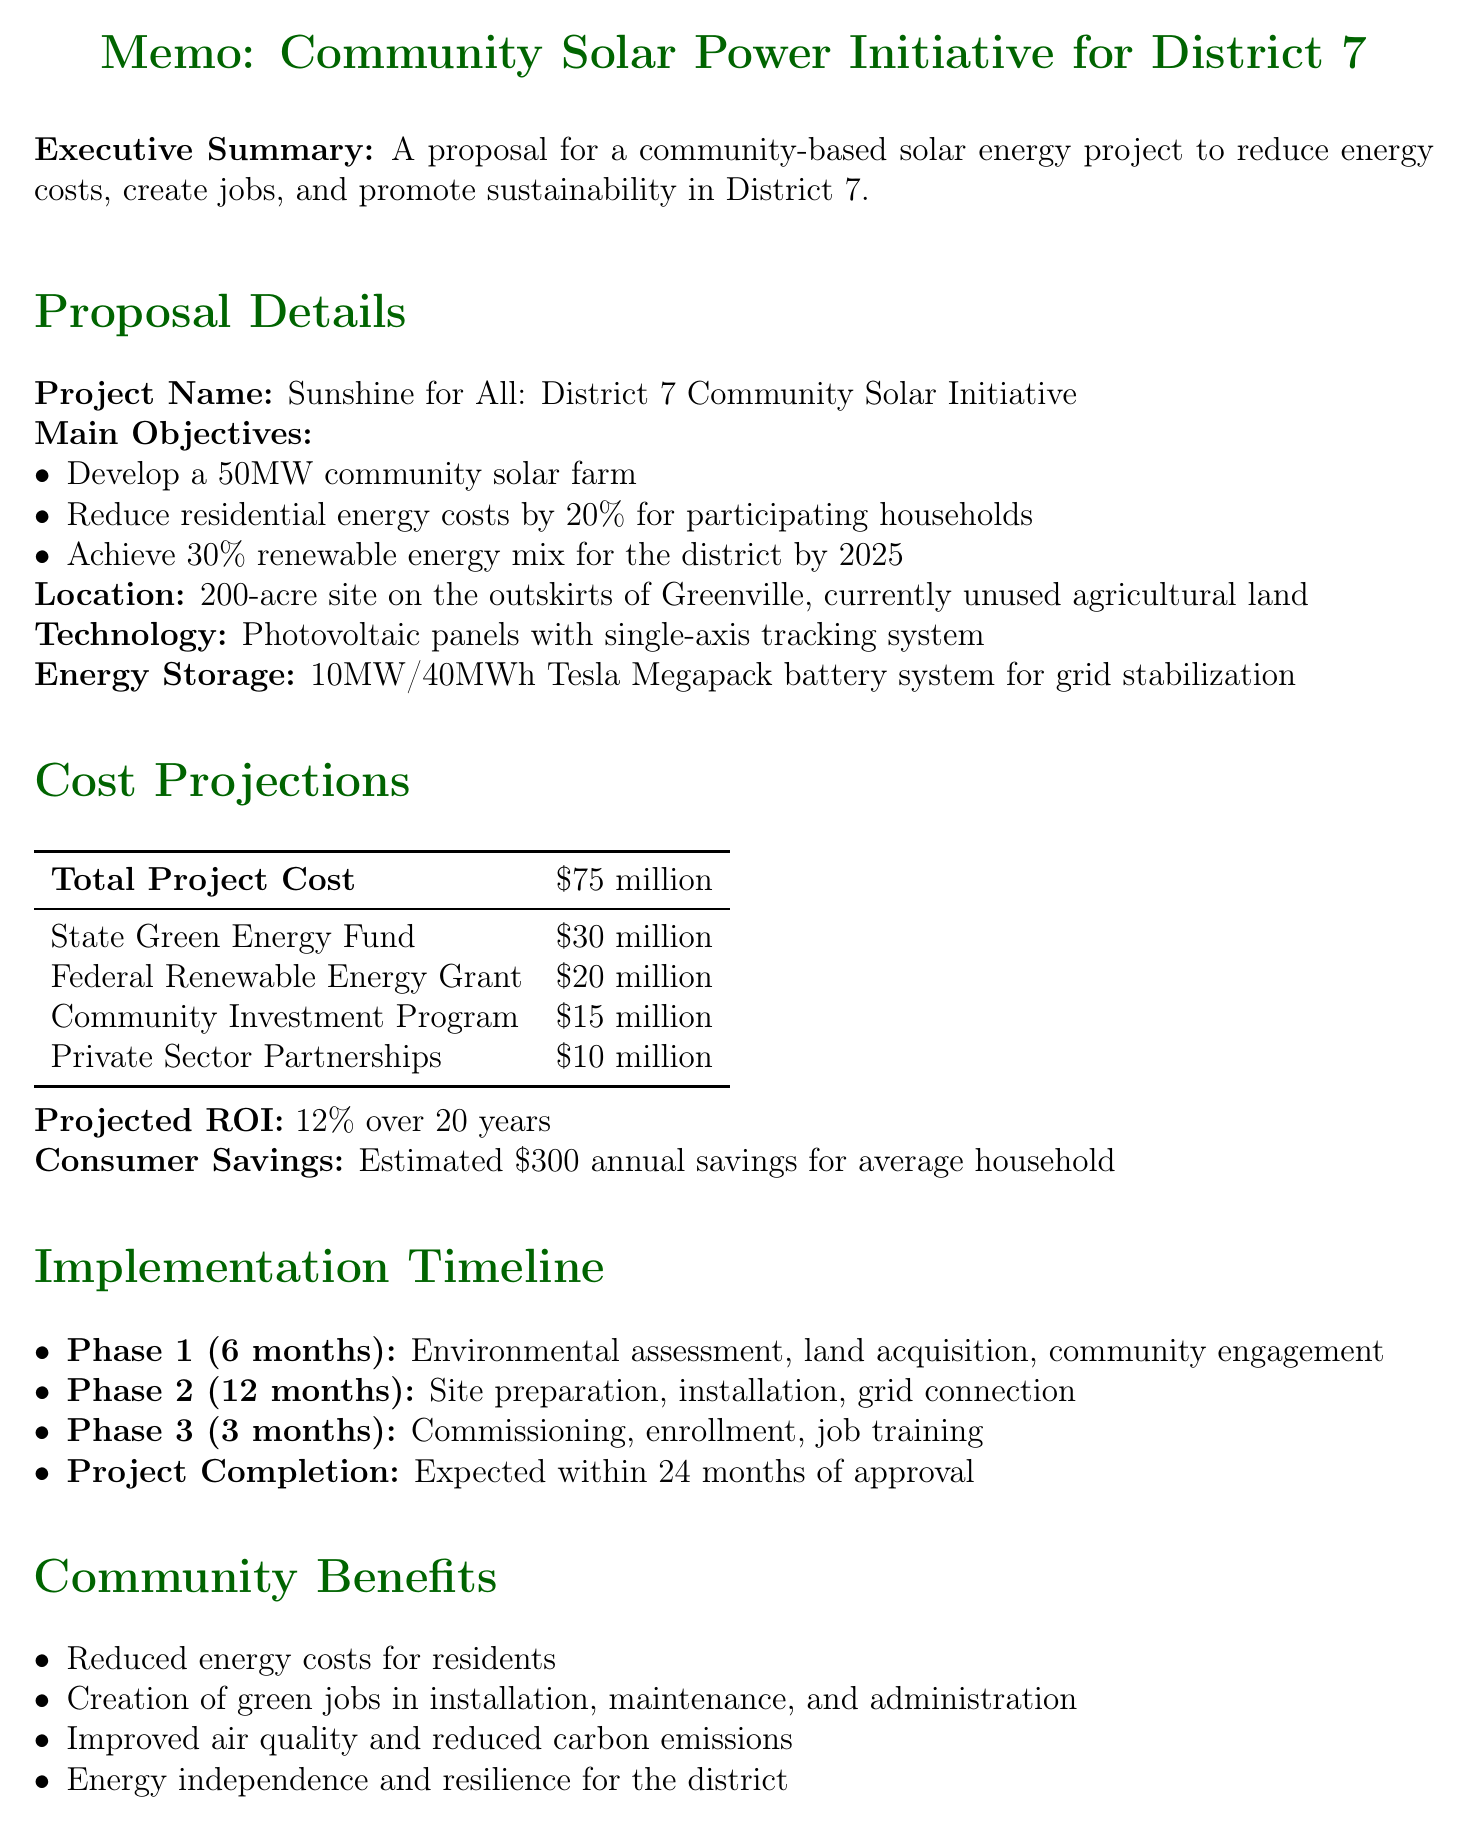What is the project name? The project name is listed as "Sunshine for All: District 7 Community Solar Initiative."
Answer: Sunshine for All: District 7 Community Solar Initiative What is the total project cost? The total project cost is mentioned directly in the cost projections section of the document.
Answer: $75 million How many new jobs are estimated to be created? The document estimates 500 new jobs in the district over the next five years based on economic potential.
Answer: 500 new jobs What percentage reduction in residential energy costs is targeted? This information is found within the main objectives of the proposal.
Answer: 20% What is the expected return on investment over 20 years? The projected ROI is explicitly stated in the cost projections section of the document.
Answer: 12% What are the three phases of implementation? The phases include environmental assessment, site preparation and installation, and system commissioning. The question refers to the phases listed in the implementation timeline.
Answer: Environmental assessment, site preparation and installation, system commissioning Which community organization is mentioned as a partner? The document lists several partners, and one specific organization from the community sector is mentioned.
Answer: Greenville Chamber of Commerce What is the anticipated completion timeline after approval? The document provides an expected completion duration from the implementation timeline.
Answer: 24 months 